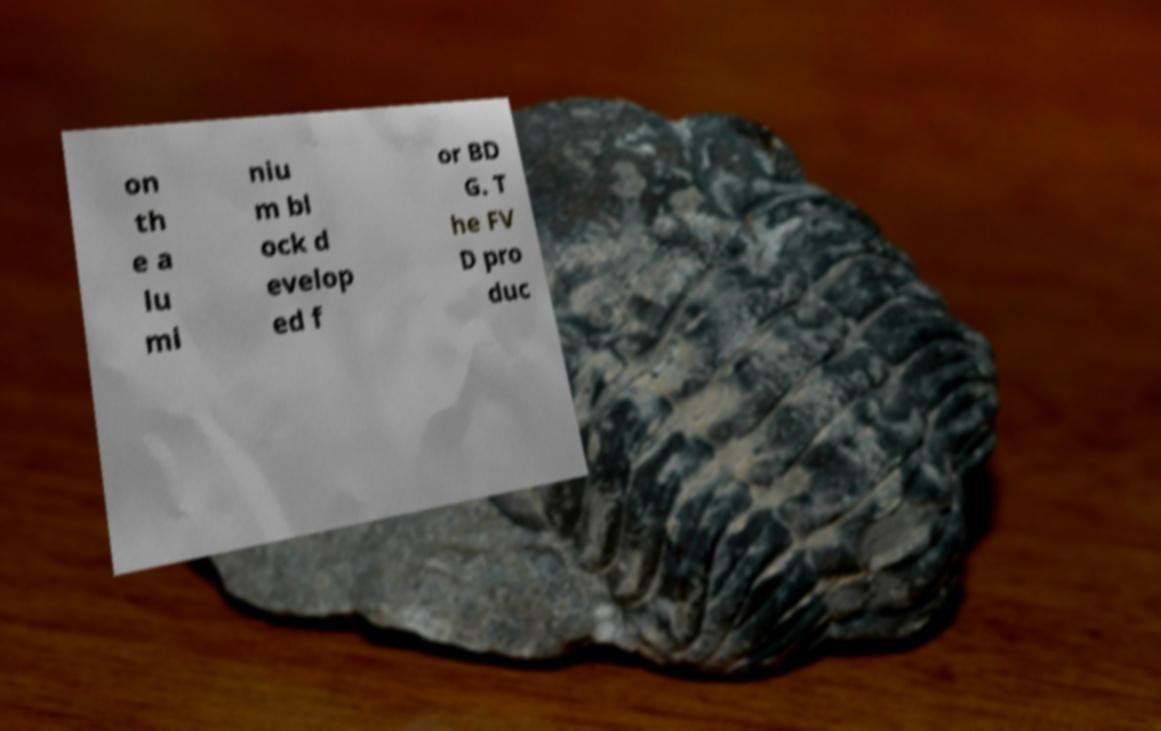Please identify and transcribe the text found in this image. on th e a lu mi niu m bl ock d evelop ed f or BD G. T he FV D pro duc 